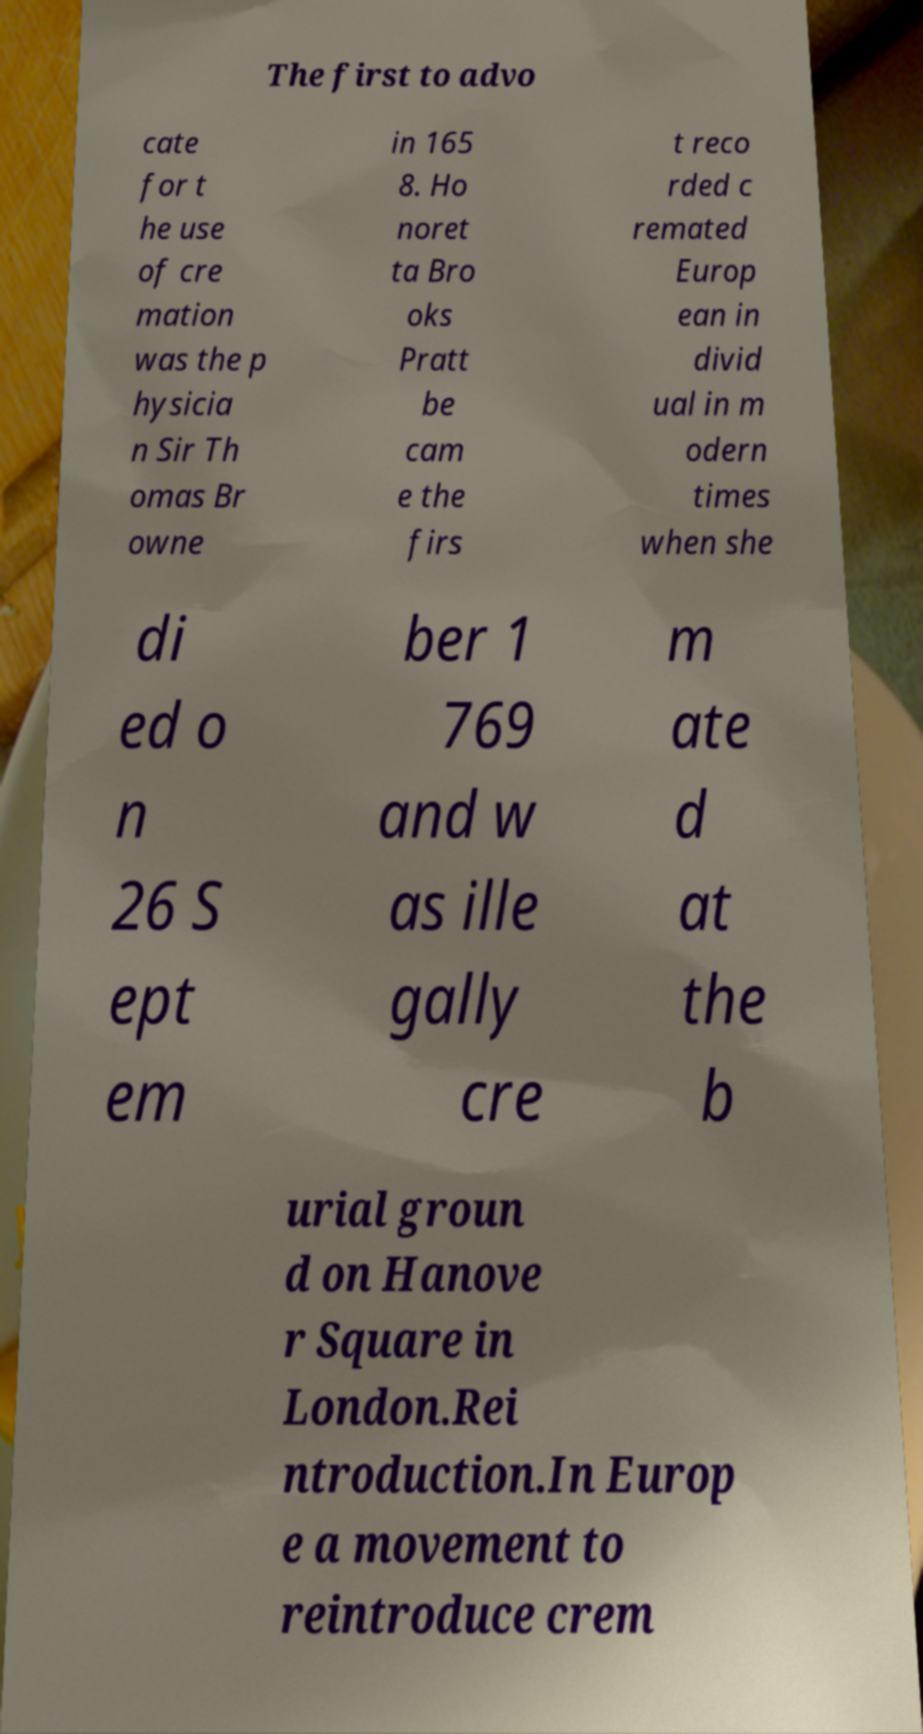There's text embedded in this image that I need extracted. Can you transcribe it verbatim? The first to advo cate for t he use of cre mation was the p hysicia n Sir Th omas Br owne in 165 8. Ho noret ta Bro oks Pratt be cam e the firs t reco rded c remated Europ ean in divid ual in m odern times when she di ed o n 26 S ept em ber 1 769 and w as ille gally cre m ate d at the b urial groun d on Hanove r Square in London.Rei ntroduction.In Europ e a movement to reintroduce crem 